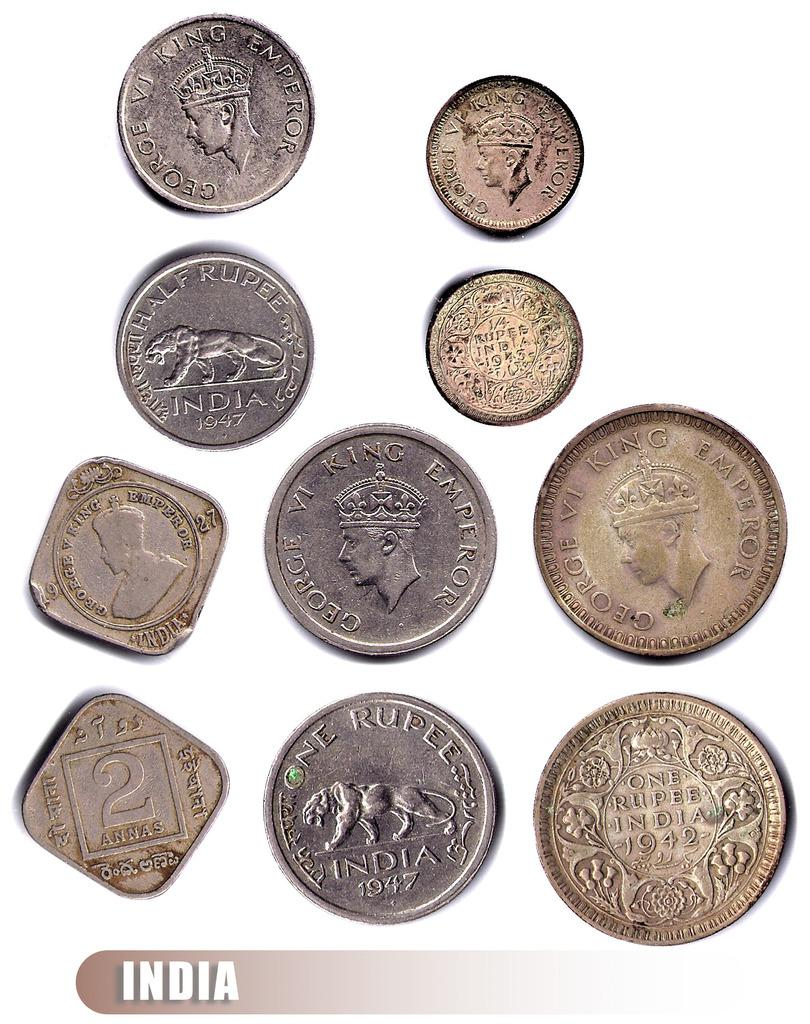<image>
Offer a succinct explanation of the picture presented. Multiple india coins that include silver and brown coins 